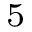Convert formula to latex. <formula><loc_0><loc_0><loc_500><loc_500>_ { 5 }</formula> 